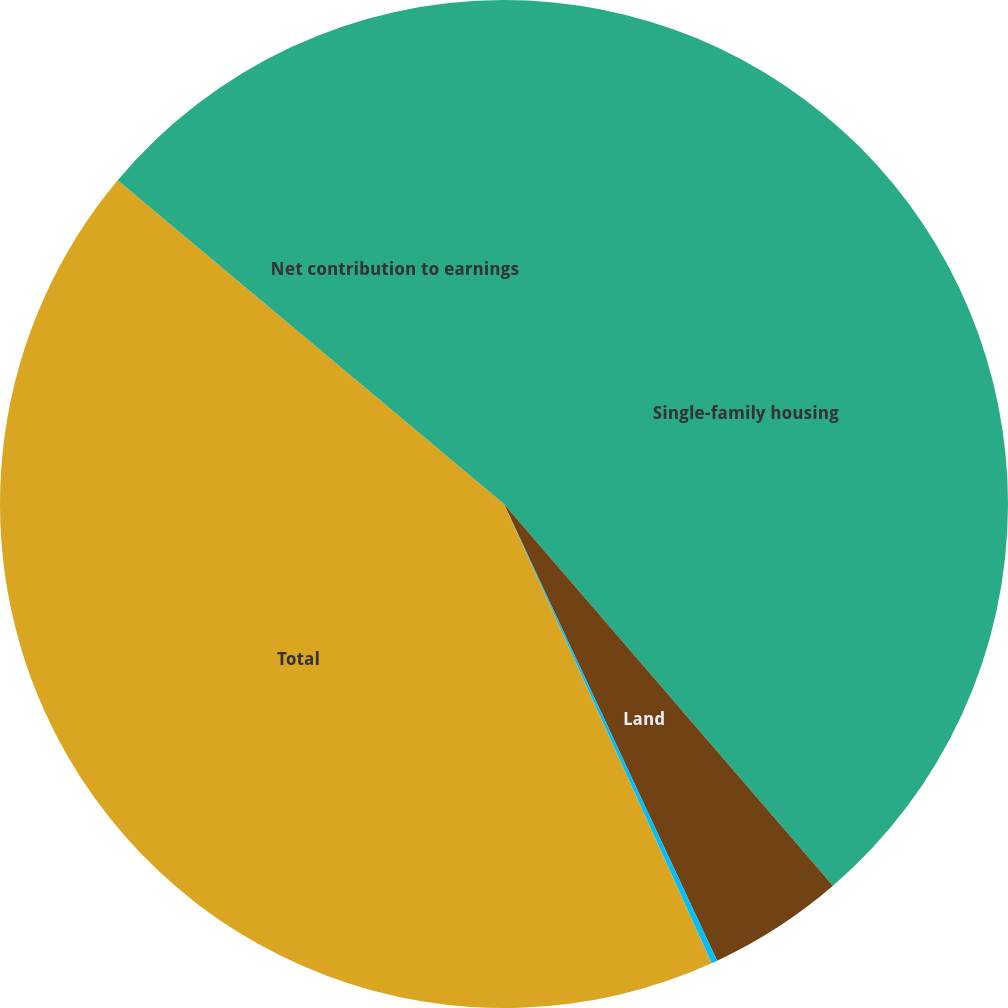Convert chart to OTSL. <chart><loc_0><loc_0><loc_500><loc_500><pie_chart><fcel>Single-family housing<fcel>Land<fcel>Other<fcel>Total<fcel>Net contribution to earnings<nl><fcel>38.68%<fcel>4.37%<fcel>0.19%<fcel>42.86%<fcel>13.9%<nl></chart> 